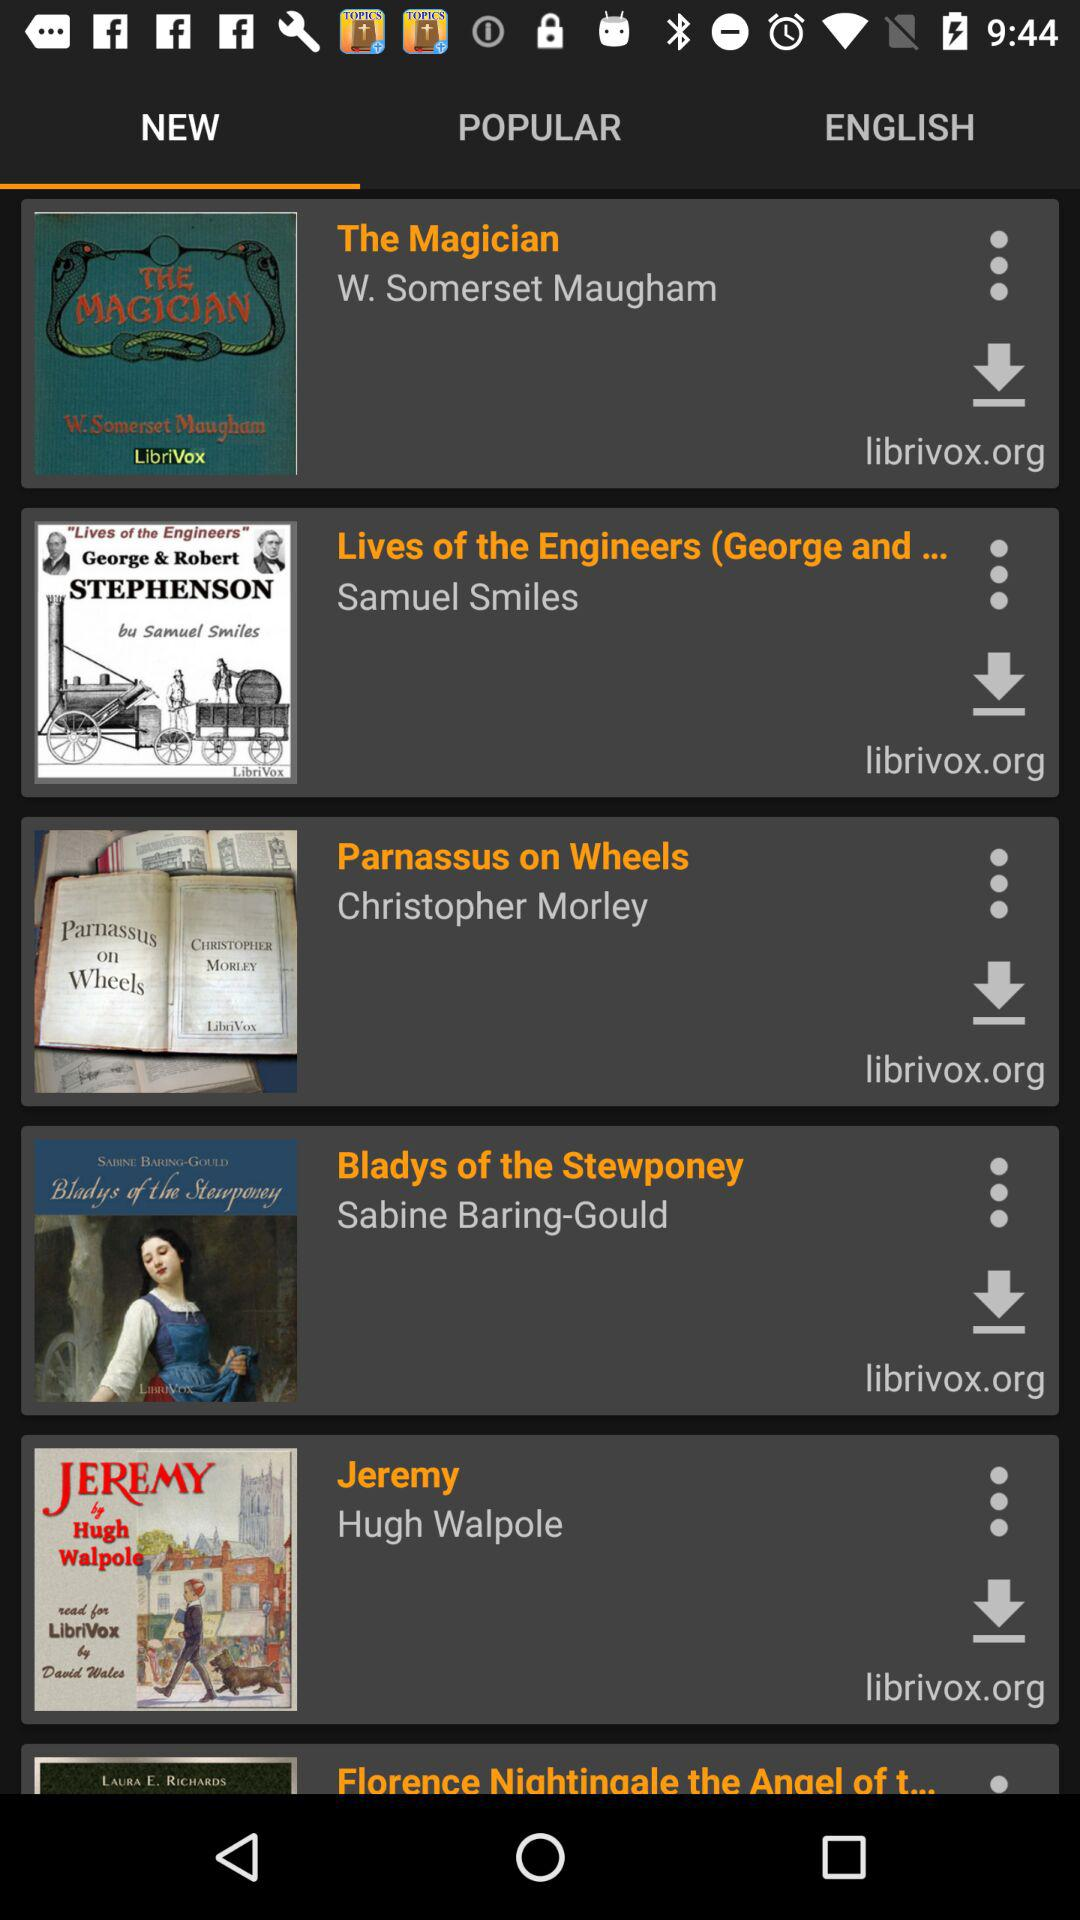Who has written the book Jeremy? The book Jeremy has written by Hugh Walpole. 